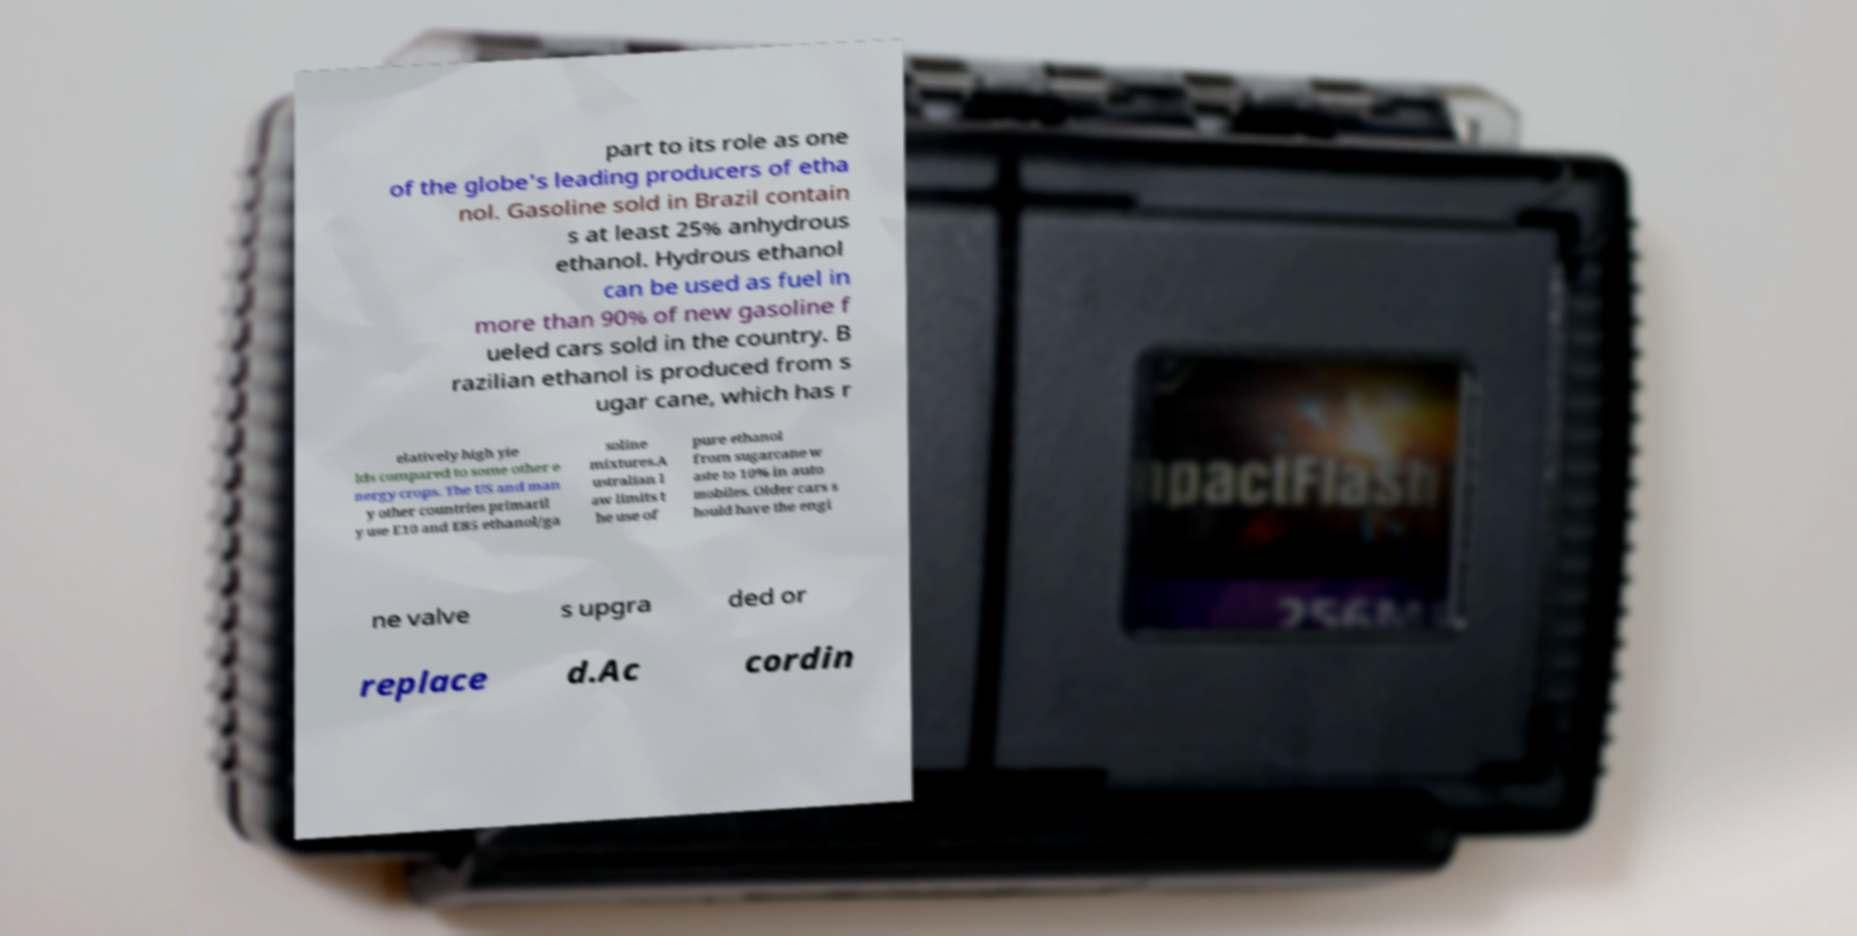There's text embedded in this image that I need extracted. Can you transcribe it verbatim? part to its role as one of the globe's leading producers of etha nol. Gasoline sold in Brazil contain s at least 25% anhydrous ethanol. Hydrous ethanol can be used as fuel in more than 90% of new gasoline f ueled cars sold in the country. B razilian ethanol is produced from s ugar cane, which has r elatively high yie lds compared to some other e nergy crops. The US and man y other countries primaril y use E10 and E85 ethanol/ga soline mixtures.A ustralian l aw limits t he use of pure ethanol from sugarcane w aste to 10% in auto mobiles. Older cars s hould have the engi ne valve s upgra ded or replace d.Ac cordin 